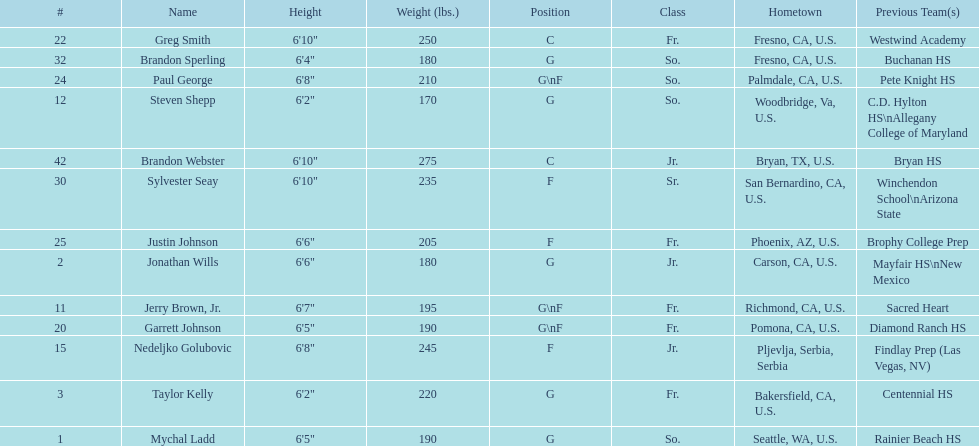Who is the next more massive participant after nedelijko golubovic? Sylvester Seay. 